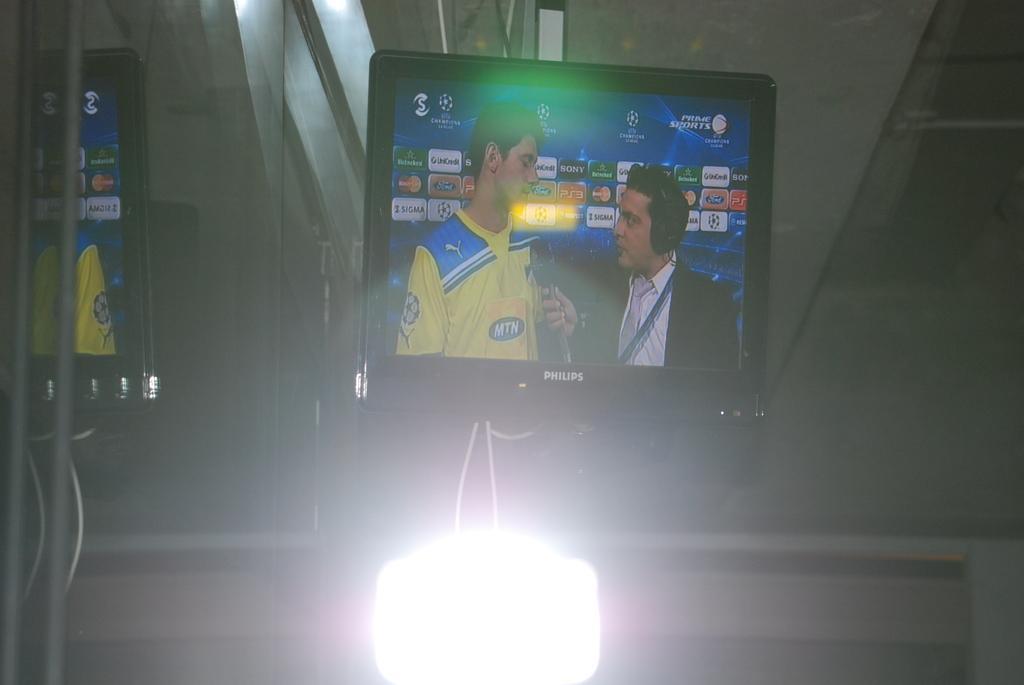<image>
Share a concise interpretation of the image provided. A sports news show says PRIME SPORTS in the upper corner. 